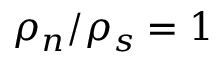Convert formula to latex. <formula><loc_0><loc_0><loc_500><loc_500>\rho _ { n } / \rho _ { s } = 1</formula> 